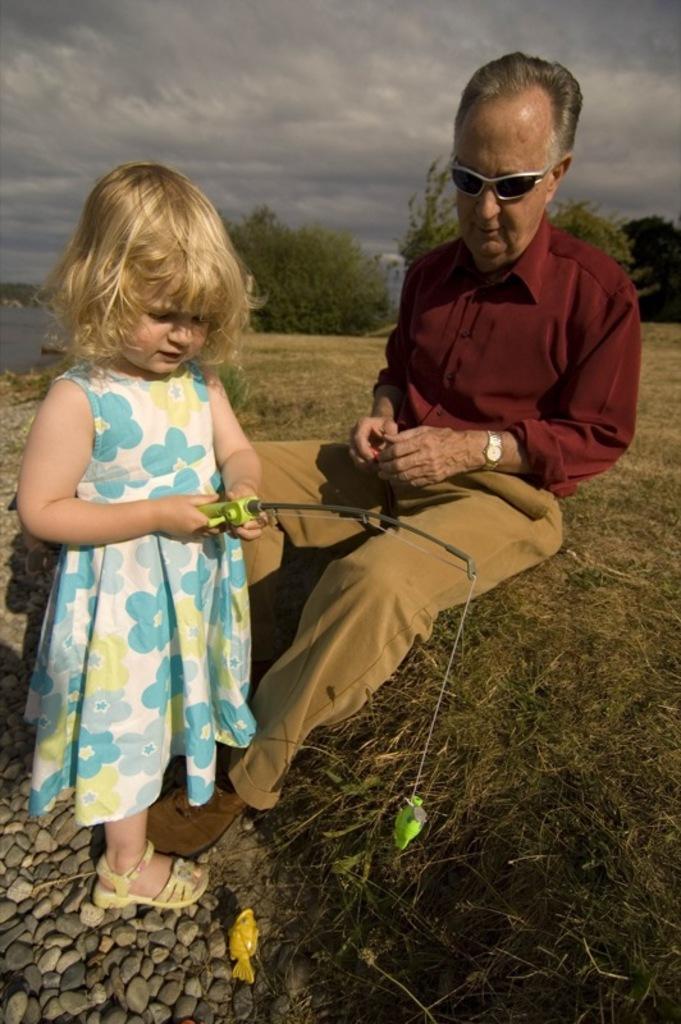Describe this image in one or two sentences. In this picture there is a man sitting on the grass, in front of him there is a girl standing and holding a fishing rod. We can see toy fish and stones. In the background of the image we can see trees, water and sky with clouds. 